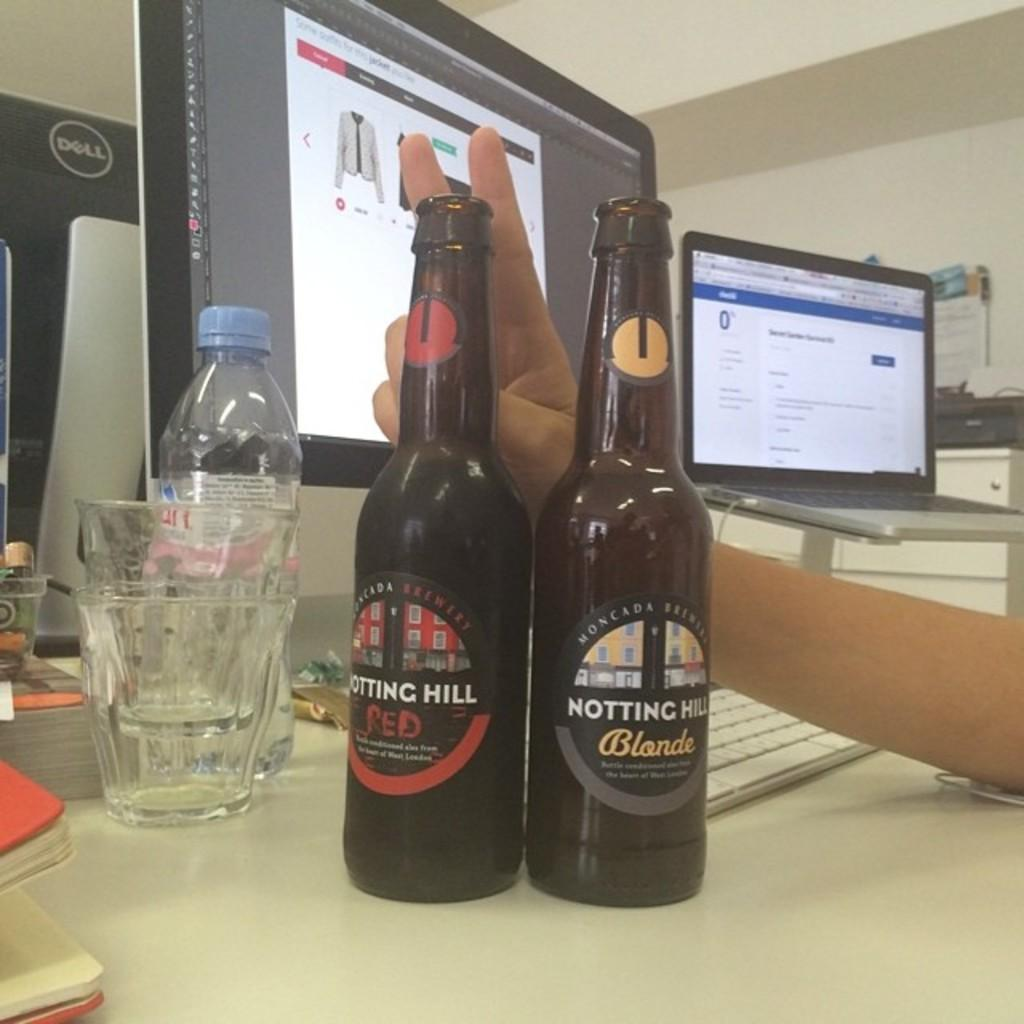Provide a one-sentence caption for the provided image. A bottle of Notting Hill Blonde and a bottle of Notting Hill Red. 